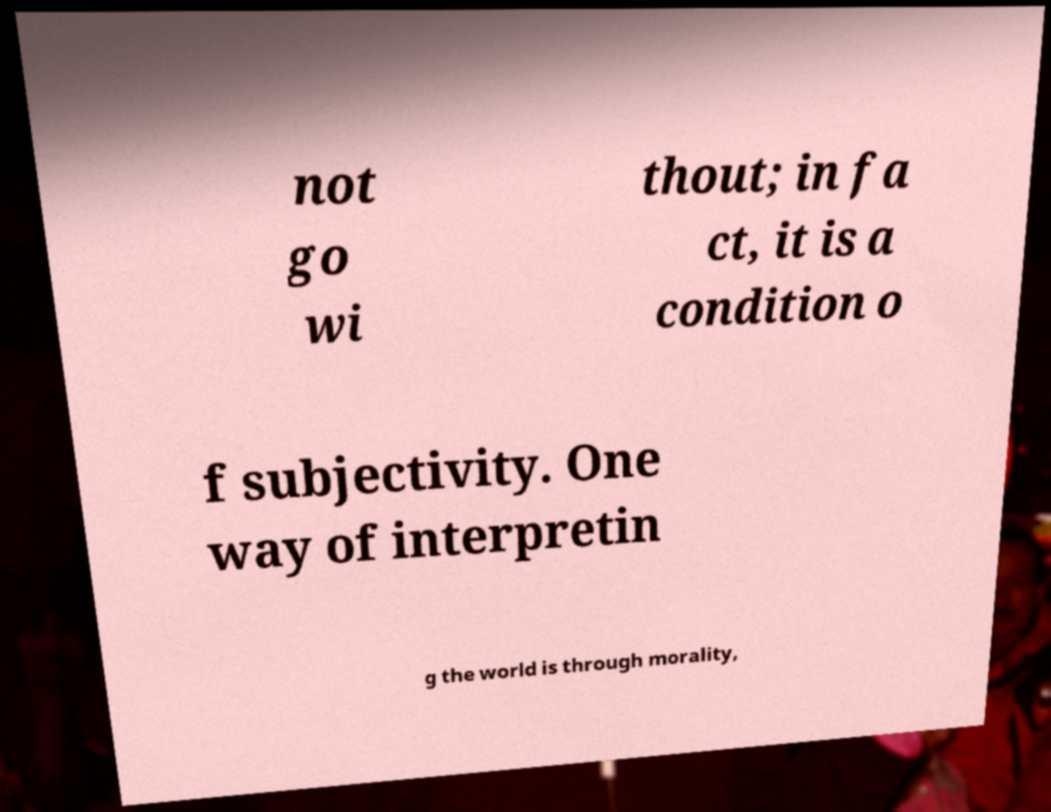There's text embedded in this image that I need extracted. Can you transcribe it verbatim? not go wi thout; in fa ct, it is a condition o f subjectivity. One way of interpretin g the world is through morality, 